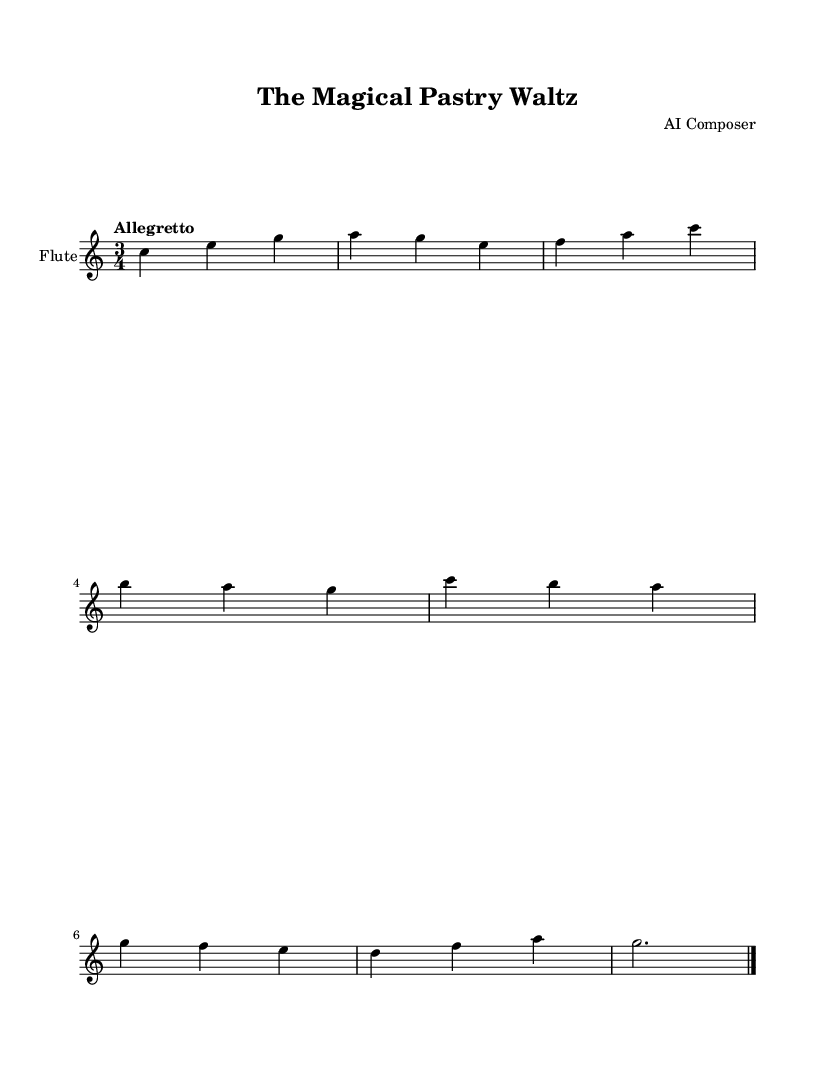What is the key signature of this music? The key signature is C major, which has no sharps or flats.
Answer: C major What is the time signature of the piece? The time signature is indicated at the beginning of the score with the fraction 3 over 4, meaning there are three beats per measure and the quarter note gets one beat.
Answer: 3/4 What is the tempo marking for this score? The tempo marking is "Allegretto," which indicates a moderately fast pace. It is specified at the beginning of the score.
Answer: Allegretto How many measures are in the piece? The score has a total of eight measures, which can be counted by looking at the vertical bars separating the musical phrases.
Answer: 8 What is the last note of the flute part? The last note is a G note, which is indicated at the end of the staff. It's a dotted half note followed by a barline, closing the piece.
Answer: G Which instrument is indicated in the score? The instrument name is specified at the top of the staff, identifying the part as a flute.
Answer: Flute What is the main rhythmic pattern in the melody? The main rhythmic pattern consists predominantly of quarter notes and eighth notes, frequently found throughout the piece.
Answer: Quarter and eighth notes 